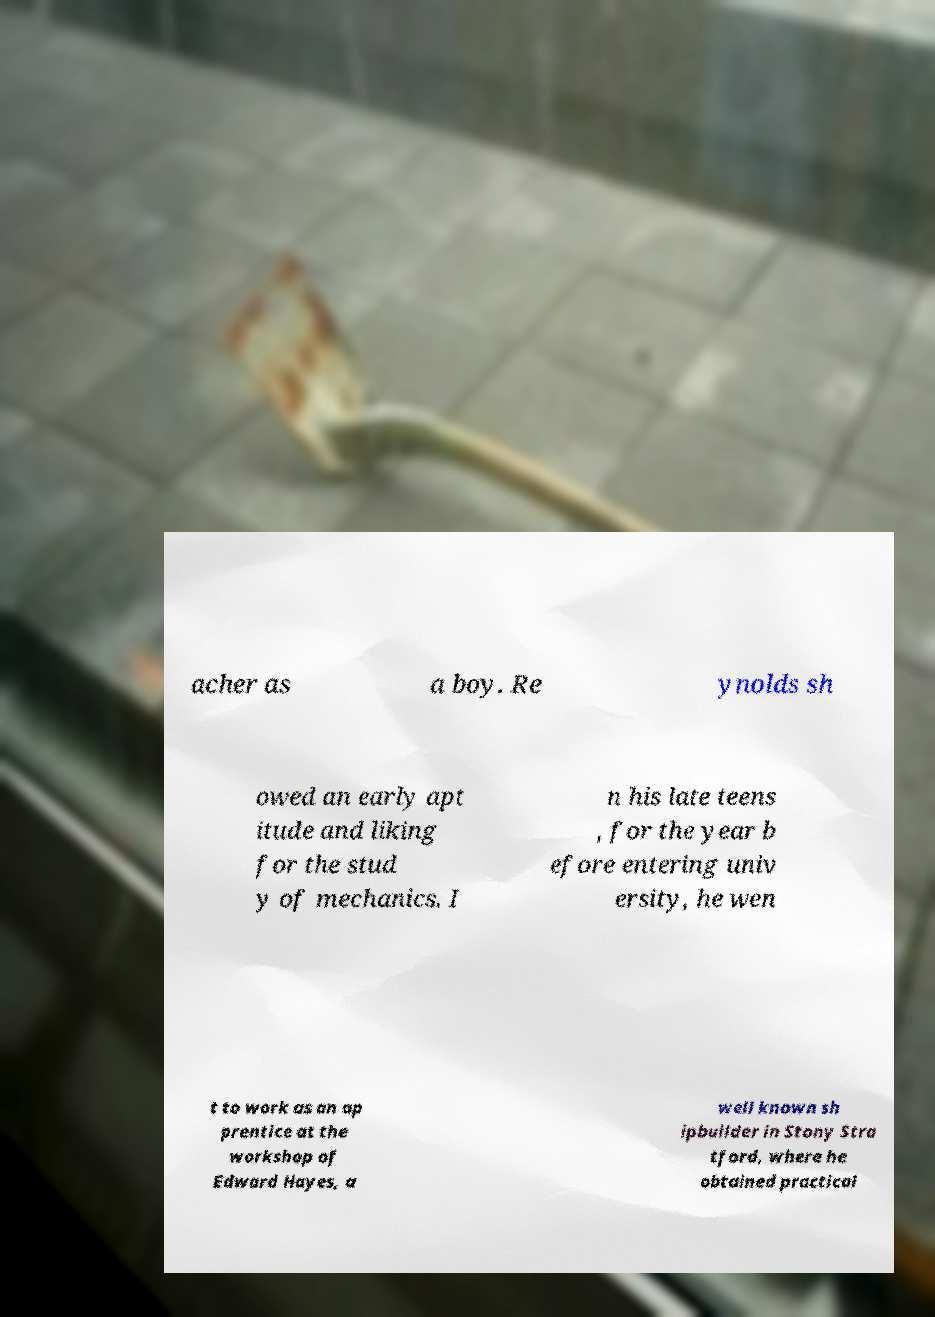Please read and relay the text visible in this image. What does it say? acher as a boy. Re ynolds sh owed an early apt itude and liking for the stud y of mechanics. I n his late teens , for the year b efore entering univ ersity, he wen t to work as an ap prentice at the workshop of Edward Hayes, a well known sh ipbuilder in Stony Stra tford, where he obtained practical 